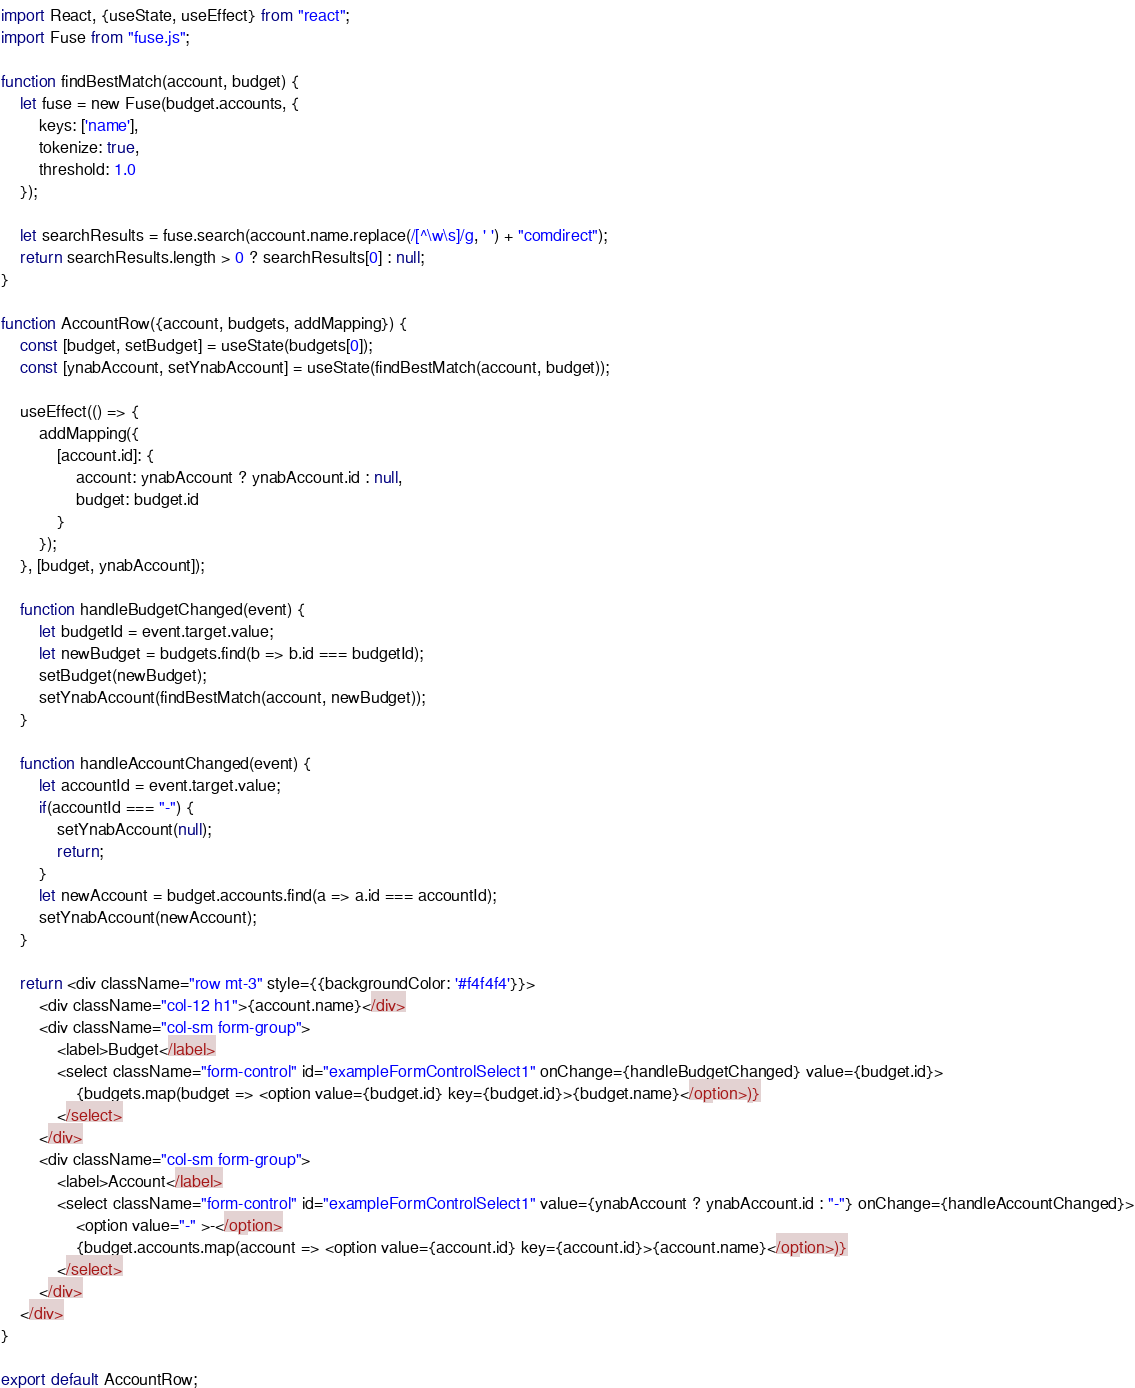<code> <loc_0><loc_0><loc_500><loc_500><_JavaScript_>import React, {useState, useEffect} from "react";
import Fuse from "fuse.js";

function findBestMatch(account, budget) {
    let fuse = new Fuse(budget.accounts, {
        keys: ['name'],
        tokenize: true,
        threshold: 1.0
    });

    let searchResults = fuse.search(account.name.replace(/[^\w\s]/g, ' ') + "comdirect");
    return searchResults.length > 0 ? searchResults[0] : null;
}

function AccountRow({account, budgets, addMapping}) {
    const [budget, setBudget] = useState(budgets[0]);
    const [ynabAccount, setYnabAccount] = useState(findBestMatch(account, budget));

    useEffect(() => {
        addMapping({
            [account.id]: {
                account: ynabAccount ? ynabAccount.id : null,
                budget: budget.id
            }
        });
    }, [budget, ynabAccount]);

    function handleBudgetChanged(event) {
        let budgetId = event.target.value;
        let newBudget = budgets.find(b => b.id === budgetId);
        setBudget(newBudget);
        setYnabAccount(findBestMatch(account, newBudget));
    }

    function handleAccountChanged(event) {
        let accountId = event.target.value;
        if(accountId === "-") {
            setYnabAccount(null);
            return;
        }
        let newAccount = budget.accounts.find(a => a.id === accountId);
        setYnabAccount(newAccount);
    }

    return <div className="row mt-3" style={{backgroundColor: '#f4f4f4'}}>
        <div className="col-12 h1">{account.name}</div>
        <div className="col-sm form-group">
            <label>Budget</label>
            <select className="form-control" id="exampleFormControlSelect1" onChange={handleBudgetChanged} value={budget.id}>
                {budgets.map(budget => <option value={budget.id} key={budget.id}>{budget.name}</option>)}
            </select>
        </div>
        <div className="col-sm form-group">
            <label>Account</label>
            <select className="form-control" id="exampleFormControlSelect1" value={ynabAccount ? ynabAccount.id : "-"} onChange={handleAccountChanged}>
                <option value="-" >-</option>
                {budget.accounts.map(account => <option value={account.id} key={account.id}>{account.name}</option>)}
            </select>
        </div>
    </div>
}

export default AccountRow;</code> 